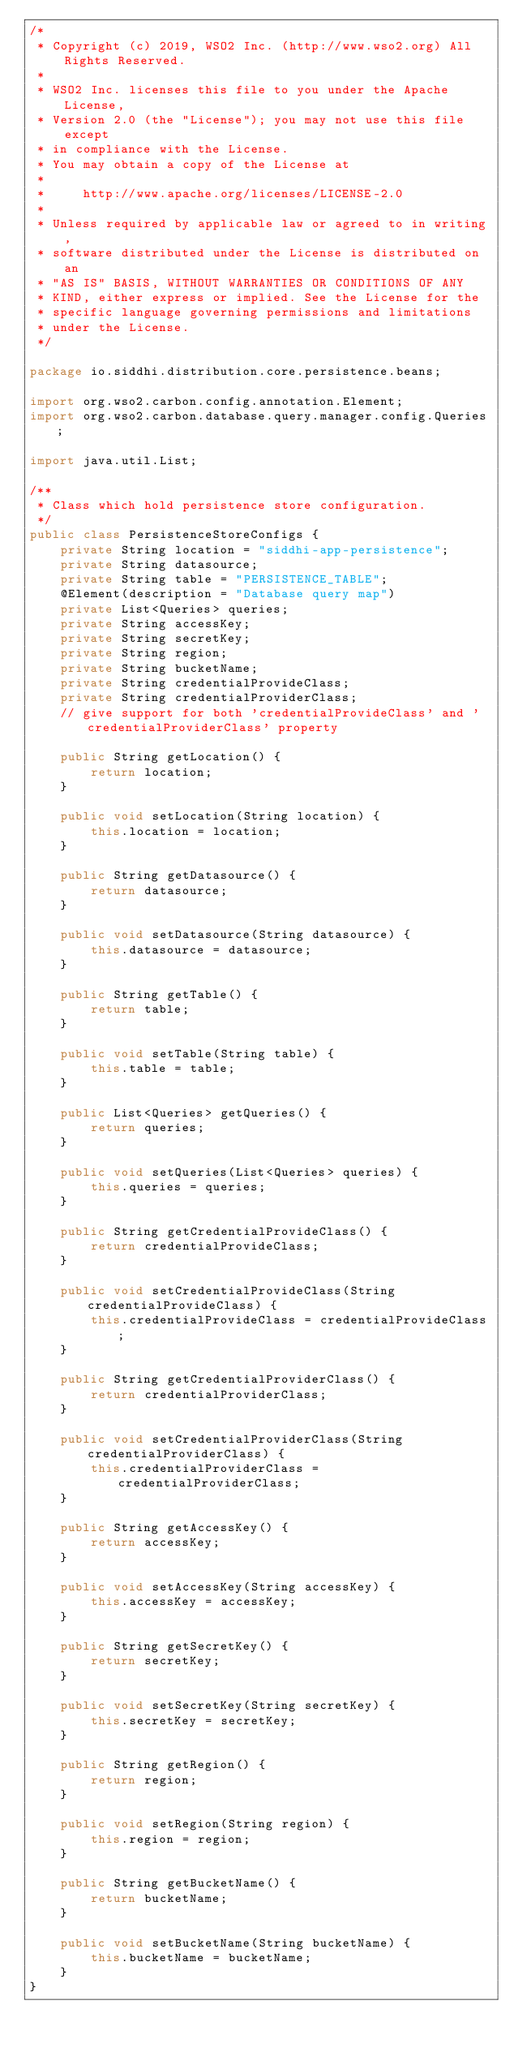<code> <loc_0><loc_0><loc_500><loc_500><_Java_>/*
 * Copyright (c) 2019, WSO2 Inc. (http://www.wso2.org) All Rights Reserved.
 *
 * WSO2 Inc. licenses this file to you under the Apache License,
 * Version 2.0 (the "License"); you may not use this file except
 * in compliance with the License.
 * You may obtain a copy of the License at
 *
 *     http://www.apache.org/licenses/LICENSE-2.0
 *
 * Unless required by applicable law or agreed to in writing,
 * software distributed under the License is distributed on an
 * "AS IS" BASIS, WITHOUT WARRANTIES OR CONDITIONS OF ANY
 * KIND, either express or implied. See the License for the
 * specific language governing permissions and limitations
 * under the License.
 */

package io.siddhi.distribution.core.persistence.beans;

import org.wso2.carbon.config.annotation.Element;
import org.wso2.carbon.database.query.manager.config.Queries;

import java.util.List;

/**
 * Class which hold persistence store configuration.
 */
public class PersistenceStoreConfigs {
    private String location = "siddhi-app-persistence";
    private String datasource;
    private String table = "PERSISTENCE_TABLE";
    @Element(description = "Database query map")
    private List<Queries> queries;
    private String accessKey;
    private String secretKey;
    private String region;
    private String bucketName;
    private String credentialProvideClass;
    private String credentialProviderClass;
    // give support for both 'credentialProvideClass' and 'credentialProviderClass' property

    public String getLocation() {
        return location;
    }

    public void setLocation(String location) {
        this.location = location;
    }

    public String getDatasource() {
        return datasource;
    }

    public void setDatasource(String datasource) {
        this.datasource = datasource;
    }

    public String getTable() {
        return table;
    }

    public void setTable(String table) {
        this.table = table;
    }

    public List<Queries> getQueries() {
        return queries;
    }

    public void setQueries(List<Queries> queries) {
        this.queries = queries;
    }

    public String getCredentialProvideClass() {
        return credentialProvideClass;
    }

    public void setCredentialProvideClass(String credentialProvideClass) {
        this.credentialProvideClass = credentialProvideClass;
    }

    public String getCredentialProviderClass() {
        return credentialProviderClass;
    }

    public void setCredentialProviderClass(String credentialProviderClass) {
        this.credentialProviderClass = credentialProviderClass;
    }

    public String getAccessKey() {
        return accessKey;
    }

    public void setAccessKey(String accessKey) {
        this.accessKey = accessKey;
    }

    public String getSecretKey() {
        return secretKey;
    }

    public void setSecretKey(String secretKey) {
        this.secretKey = secretKey;
    }

    public String getRegion() {
        return region;
    }

    public void setRegion(String region) {
        this.region = region;
    }

    public String getBucketName() {
        return bucketName;
    }

    public void setBucketName(String bucketName) {
        this.bucketName = bucketName;
    }
}
</code> 